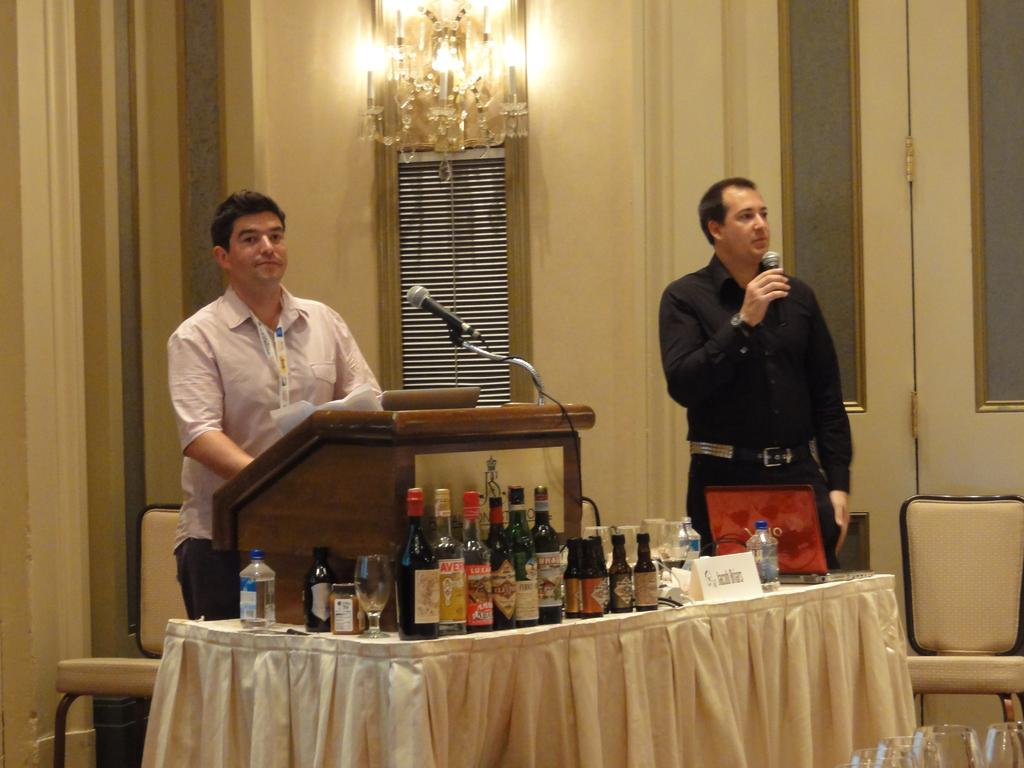How many people are in the image? There are two people in the image. What are the people holding in their hands? The people are holding microphones. Where are the people standing in relation to the desk? The people are standing in front of a desk. What can be seen on the table in the image? There are bottles on the table. What type of skin is visible on the people in the image? There is no information about the skin of the people in the image, as the focus is on their actions and the objects they are holding. 